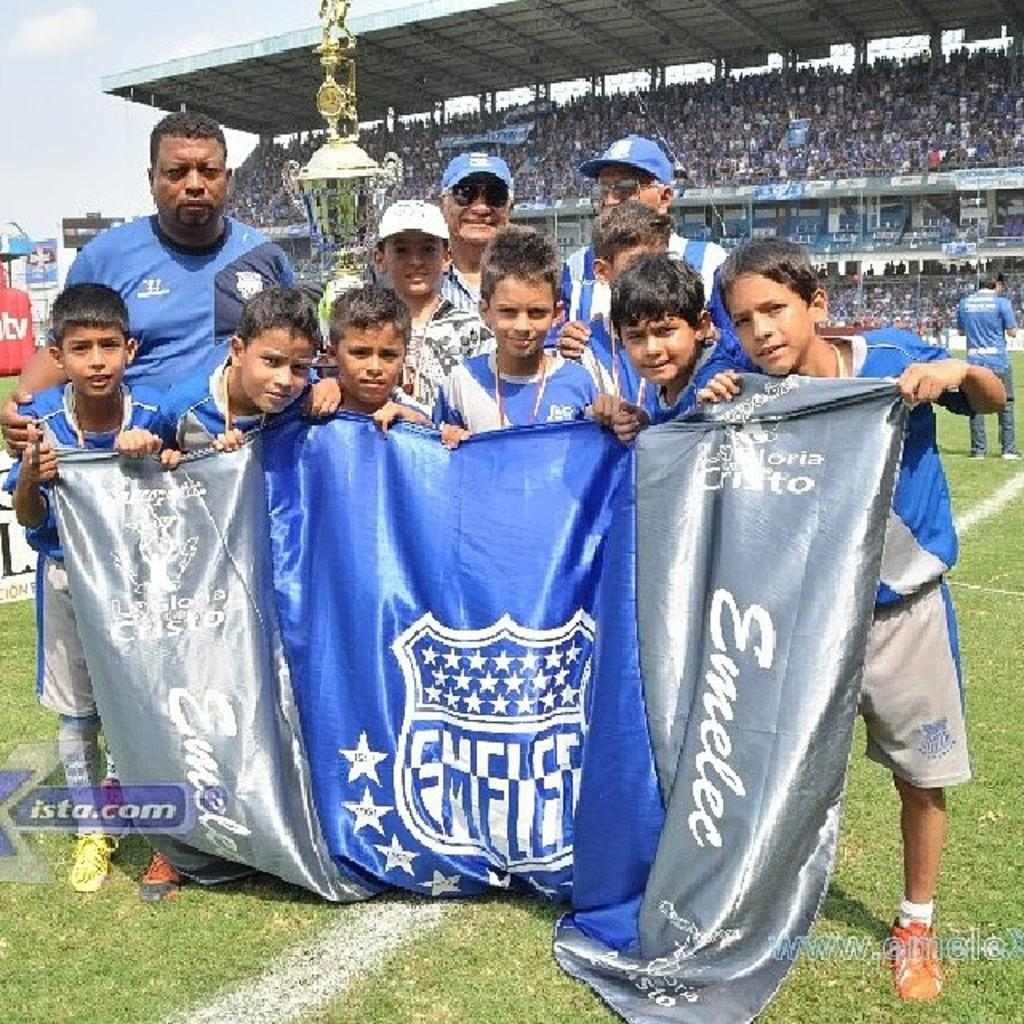<image>
Provide a brief description of the given image. Children on a baseball field holding out a blue and silver banner for Emelec 